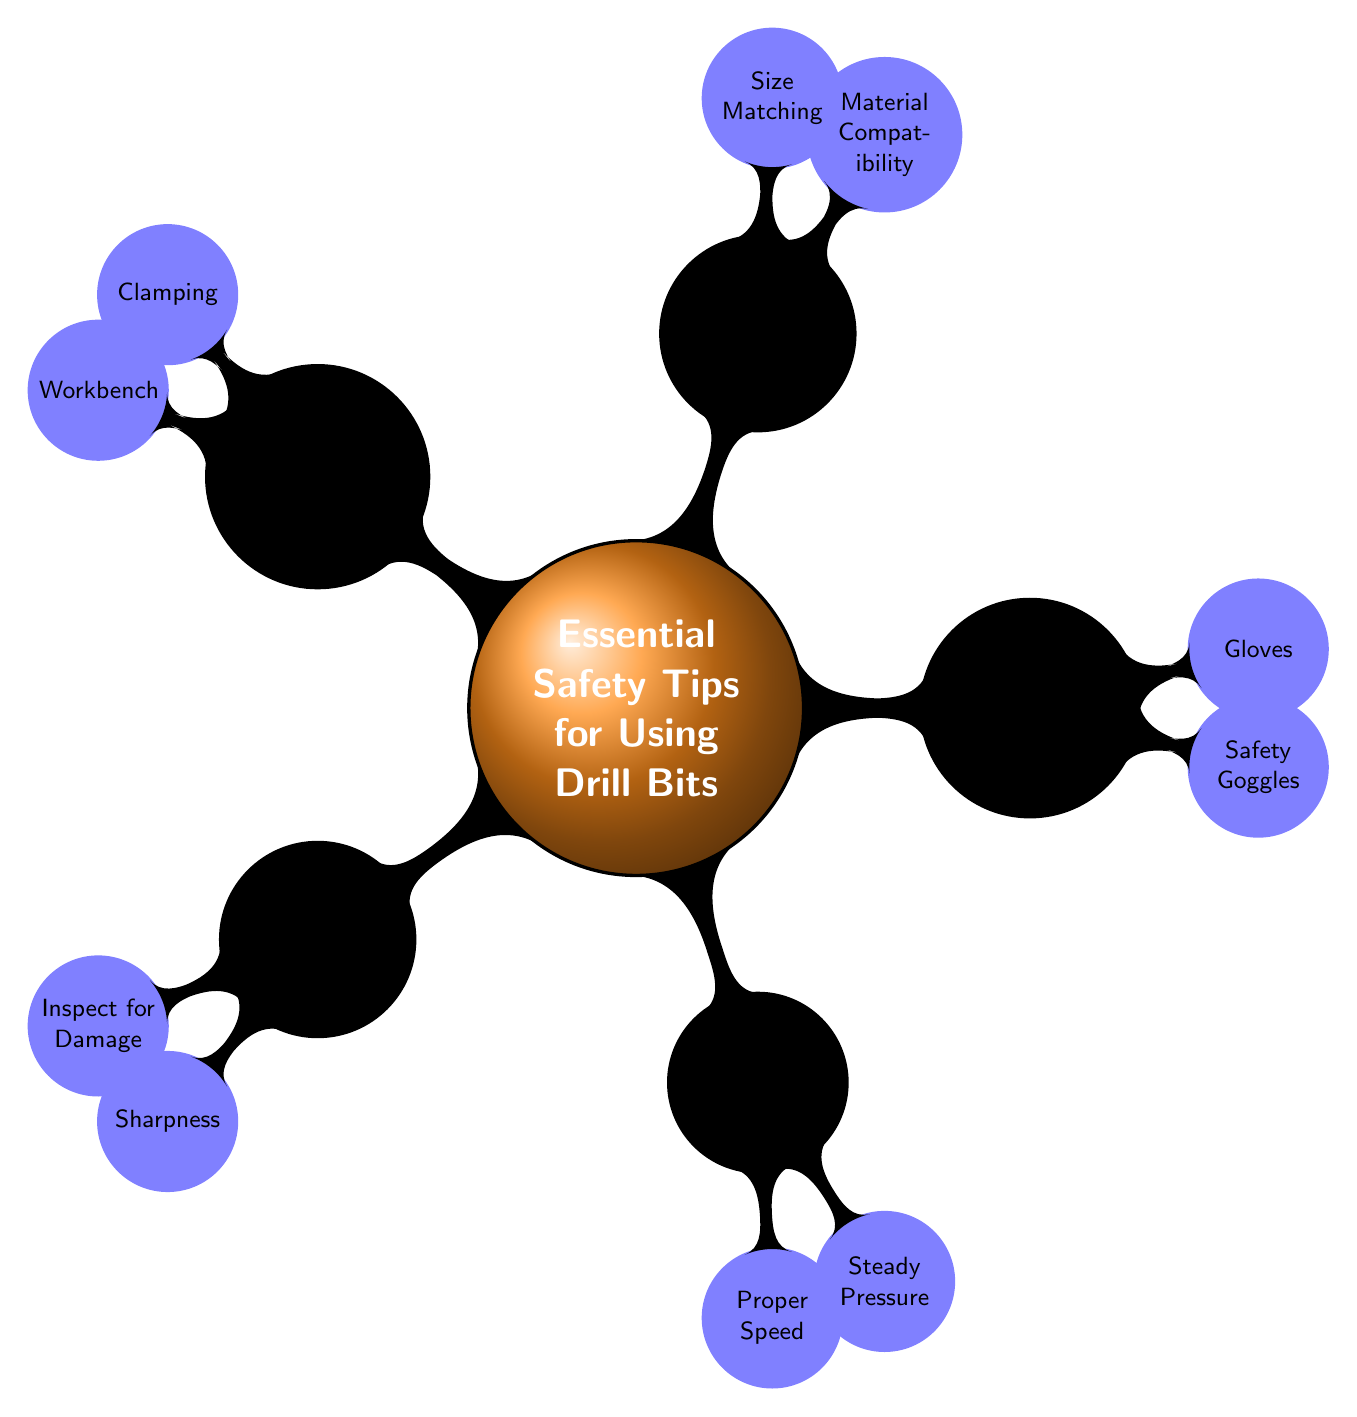What is the main topic of the mind map? The central concept of the mind map is identified at the top node labeled "Essential Safety Tips for Using Drill Bits." This is the overall theme that all other nodes revolve around.
Answer: Essential Safety Tips for Using Drill Bits How many main branches are there? The diagram shows five main branches stemming from the central node, each representing a distinct safety tip category.
Answer: 5 What is one type of safety gear mentioned? The mind map includes a branch titled "Wear Proper Safety Gear," which has sub-nodes, one of which specifies "Safety Goggles" as a type of safety gear.
Answer: Safety Goggles What are two aspects of drill maintenance? Under the "Drill Maintenance" branch, there are two sub-nodes: "Inspect for Damage" and "Sharpness" are both necessary aspects of maintaining drill bits.
Answer: Inspect for Damage and Sharpness How should the drill speed be adjusted? Within the "Drilling Technique" section, "Proper Speed" indicates that the drill speed must be adjusted based on the material being drilled. This is essential for effective usage.
Answer: Adjust according to the material What is necessary for securing the workpiece? The mind map highlights "Clamping" under the "Secure Your Workpiece" branch, illustrating the importance of clamps for holding the workpiece in place.
Answer: Clamping How does one ensure correct material compatibility for drill bits? In the "Choose the Right Drill Bit" branch, "Material Compatibility" emphasizes that selecting drill bits specifically designed for the material being worked on is necessary for efficiency and safety.
Answer: Select bits designed for the material What is the recommended technique for applying pressure during drilling? The "Drilling Technique" branch advises to apply "Steady Pressure," indicating that consistently exerting pressure during drilling is important to prevent tool damage.
Answer: Steady Pressure How many types of safety gear are listed in the diagram? The "Wear Proper Safety Gear" branch features two sub-nodes, one for "Safety Goggles" and one for "Gloves," thus showcasing two distinct types of safety gear mentioned.
Answer: 2 